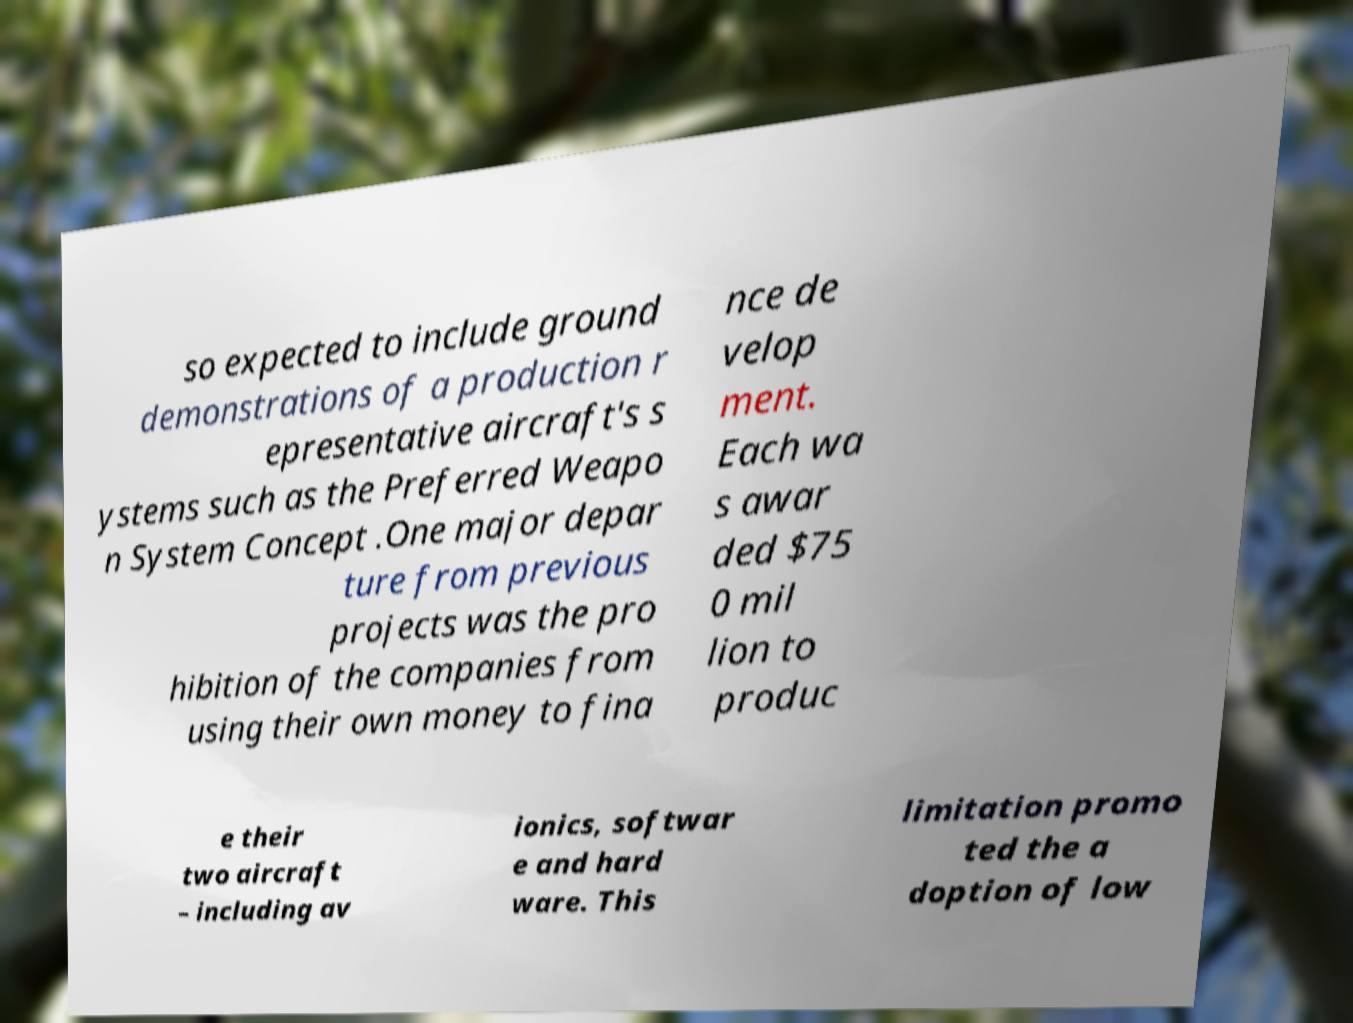What messages or text are displayed in this image? I need them in a readable, typed format. so expected to include ground demonstrations of a production r epresentative aircraft's s ystems such as the Preferred Weapo n System Concept .One major depar ture from previous projects was the pro hibition of the companies from using their own money to fina nce de velop ment. Each wa s awar ded $75 0 mil lion to produc e their two aircraft – including av ionics, softwar e and hard ware. This limitation promo ted the a doption of low 